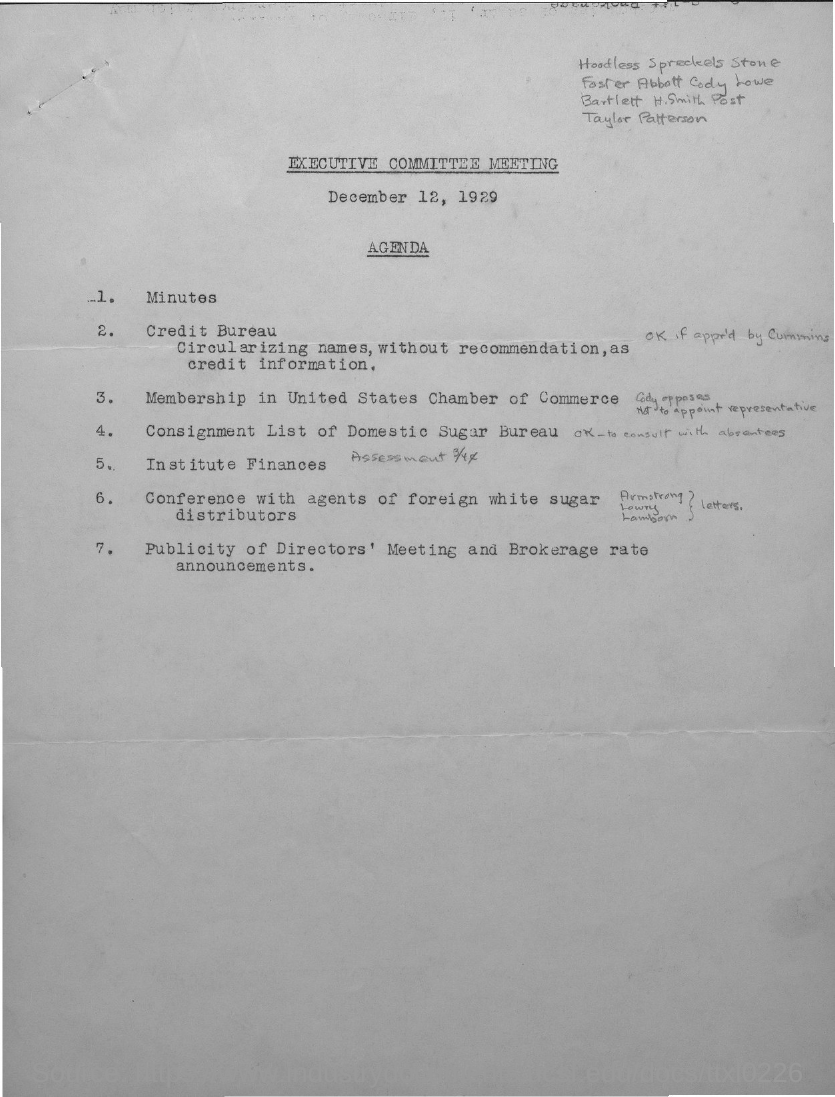When is the executive committee meeting held?
Your answer should be very brief. December 12, 1929. 